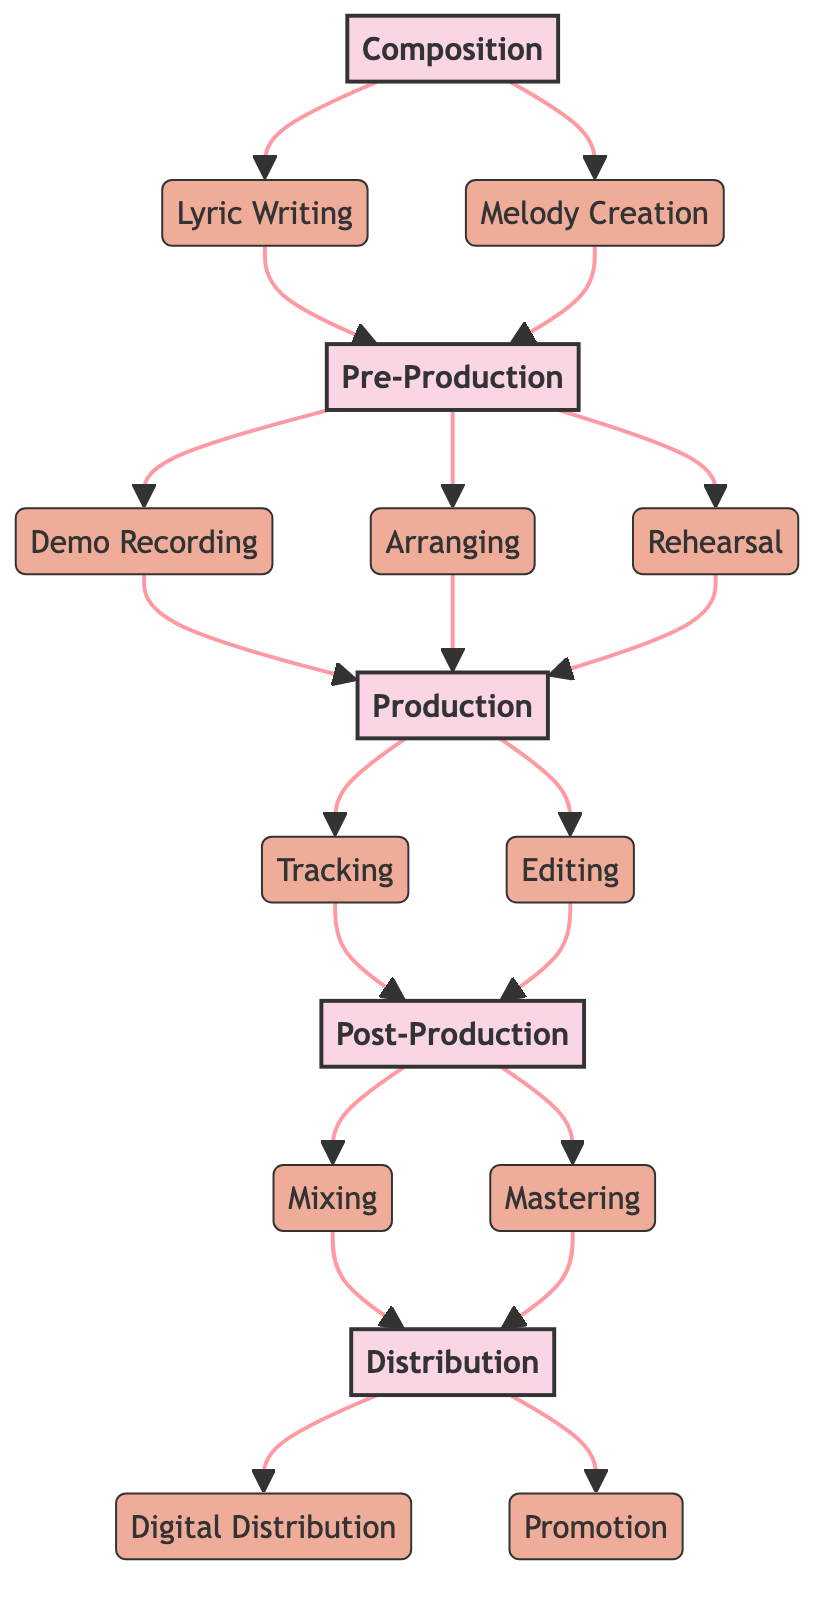What are the steps involved in the Composition stage? The Composition stage consists of two steps: Lyric Writing and Melody Creation. Both are essential for establishing the foundation of a song.
Answer: Lyric Writing, Melody Creation How many steps are in the Pre-Production stage? The Pre-Production stage includes three steps: Demo Recording, Arranging, and Rehearsal. Counting these steps gives a total of three.
Answer: 3 What stage comes after Production? Following Production, the next stage in the journey is Post-Production. This sequence is clear from the progression through the stages in the diagram.
Answer: Post-Production Which step involves balancing song elements? The step that focuses on balancing all elements of the song is Mixing. This is part of the Post-Production stage.
Answer: Mixing What are the two main steps in Distribution? The Distribution stage consists of Digital Distribution and Promotion, which are the key activities that occur after finalizing the song.
Answer: Digital Distribution, Promotion Which step follows Editing? After the Editing step within the Production stage, the next step is Post-Production. This can be determined by tracing the arrows in the diagram.
Answer: Post-Production How many stages are there in total? The diagram outlines five stages in the music production pathway, counting all major sections from Composition to Distribution.
Answer: 5 What is the primary focus of the Production stage? The main focus of the Production stage is on Tracking and Editing, which involve recording and refining the music.
Answer: Tracking, Editing What is the ultimate goal of the Distribution stage? The ultimate goal of the Distribution stage is to release and promote the song for listeners, ensuring it reaches a wider audience.
Answer: Release and promote the song 